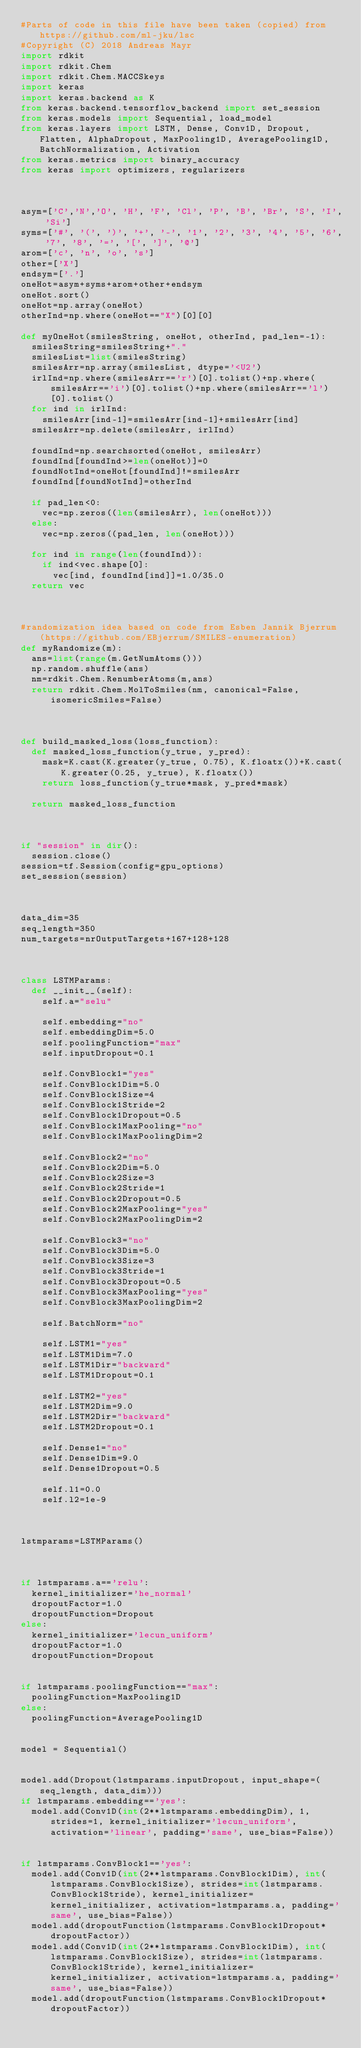<code> <loc_0><loc_0><loc_500><loc_500><_Python_>#Parts of code in this file have been taken (copied) from https://github.com/ml-jku/lsc
#Copyright (C) 2018 Andreas Mayr
import rdkit
import rdkit.Chem
import rdkit.Chem.MACCSkeys
import keras
import keras.backend as K
from keras.backend.tensorflow_backend import set_session
from keras.models import Sequential, load_model
from keras.layers import LSTM, Dense, Conv1D, Dropout, Flatten, AlphaDropout, MaxPooling1D, AveragePooling1D, BatchNormalization, Activation
from keras.metrics import binary_accuracy
from keras import optimizers, regularizers



asym=['C','N','O', 'H', 'F', 'Cl', 'P', 'B', 'Br', 'S', 'I', 'Si']
syms=['#', '(', ')', '+', '-', '1', '2', '3', '4', '5', '6', '7', '8', '=', '[', ']', '@']
arom=['c', 'n', 'o', 's']
other=['X']
endsym=['.']
oneHot=asym+syms+arom+other+endsym
oneHot.sort()
oneHot=np.array(oneHot)
otherInd=np.where(oneHot=="X")[0][0]

def myOneHot(smilesString, oneHot, otherInd, pad_len=-1):
  smilesString=smilesString+"."
  smilesList=list(smilesString)
  smilesArr=np.array(smilesList, dtype='<U2')
  irlInd=np.where(smilesArr=='r')[0].tolist()+np.where(smilesArr=='i')[0].tolist()+np.where(smilesArr=='l')[0].tolist()
  for ind in irlInd:
    smilesArr[ind-1]=smilesArr[ind-1]+smilesArr[ind]
  smilesArr=np.delete(smilesArr, irlInd)

  foundInd=np.searchsorted(oneHot, smilesArr)
  foundInd[foundInd>=len(oneHot)]=0
  foundNotInd=oneHot[foundInd]!=smilesArr
  foundInd[foundNotInd]=otherInd

  if pad_len<0:
    vec=np.zeros((len(smilesArr), len(oneHot)))
  else:
    vec=np.zeros((pad_len, len(oneHot)))

  for ind in range(len(foundInd)):
    if ind<vec.shape[0]:
      vec[ind, foundInd[ind]]=1.0/35.0
  return vec



#randomization idea based on code from Esben Jannik Bjerrum (https://github.com/EBjerrum/SMILES-enumeration)
def myRandomize(m):
  ans=list(range(m.GetNumAtoms()))
  np.random.shuffle(ans)
  nm=rdkit.Chem.RenumberAtoms(m,ans)
  return rdkit.Chem.MolToSmiles(nm, canonical=False, isomericSmiles=False)



def build_masked_loss(loss_function):
  def masked_loss_function(y_true, y_pred):
    mask=K.cast(K.greater(y_true, 0.75), K.floatx())+K.cast(K.greater(0.25, y_true), K.floatx())
    return loss_function(y_true*mask, y_pred*mask)

  return masked_loss_function



if "session" in dir():
  session.close()
session=tf.Session(config=gpu_options)
set_session(session)



data_dim=35
seq_length=350
num_targets=nrOutputTargets+167+128+128



class LSTMParams:
  def __init__(self):
    self.a="selu"
    
    self.embedding="no"
    self.embeddingDim=5.0
    self.poolingFunction="max"
    self.inputDropout=0.1

    self.ConvBlock1="yes"
    self.ConvBlock1Dim=5.0
    self.ConvBlock1Size=4
    self.ConvBlock1Stride=2
    self.ConvBlock1Dropout=0.5
    self.ConvBlock1MaxPooling="no"
    self.ConvBlock1MaxPoolingDim=2

    self.ConvBlock2="no"
    self.ConvBlock2Dim=5.0
    self.ConvBlock2Size=3
    self.ConvBlock2Stride=1
    self.ConvBlock2Dropout=0.5
    self.ConvBlock2MaxPooling="yes"
    self.ConvBlock2MaxPoolingDim=2

    self.ConvBlock3="no"
    self.ConvBlock3Dim=5.0
    self.ConvBlock3Size=3
    self.ConvBlock3Stride=1
    self.ConvBlock3Dropout=0.5
    self.ConvBlock3MaxPooling="yes"
    self.ConvBlock3MaxPoolingDim=2

    self.BatchNorm="no"

    self.LSTM1="yes"
    self.LSTM1Dim=7.0
    self.LSTM1Dir="backward"
    self.LSTM1Dropout=0.1

    self.LSTM2="yes"
    self.LSTM2Dim=9.0
    self.LSTM2Dir="backward"
    self.LSTM2Dropout=0.1

    self.Dense1="no"
    self.Dense1Dim=9.0
    self.Dense1Dropout=0.5

    self.l1=0.0
    self.l2=1e-9



lstmparams=LSTMParams()



if lstmparams.a=='relu':
  kernel_initializer='he_normal'
  dropoutFactor=1.0
  dropoutFunction=Dropout
else:
  kernel_initializer='lecun_uniform'
  dropoutFactor=1.0
  dropoutFunction=Dropout

    
if lstmparams.poolingFunction=="max":
  poolingFunction=MaxPooling1D
else:
  poolingFunction=AveragePooling1D


model = Sequential()


model.add(Dropout(lstmparams.inputDropout, input_shape=(seq_length, data_dim)))
if lstmparams.embedding=='yes':
  model.add(Conv1D(int(2**lstmparams.embeddingDim), 1, strides=1, kernel_initializer='lecun_uniform', activation='linear', padding='same', use_bias=False))


if lstmparams.ConvBlock1=='yes':
  model.add(Conv1D(int(2**lstmparams.ConvBlock1Dim), int(lstmparams.ConvBlock1Size), strides=int(lstmparams.ConvBlock1Stride), kernel_initializer=kernel_initializer, activation=lstmparams.a, padding='same', use_bias=False))
  model.add(dropoutFunction(lstmparams.ConvBlock1Dropout*dropoutFactor))
  model.add(Conv1D(int(2**lstmparams.ConvBlock1Dim), int(lstmparams.ConvBlock1Size), strides=int(lstmparams.ConvBlock1Stride), kernel_initializer=kernel_initializer, activation=lstmparams.a, padding='same', use_bias=False))
  model.add(dropoutFunction(lstmparams.ConvBlock1Dropout*dropoutFactor))
    </code> 